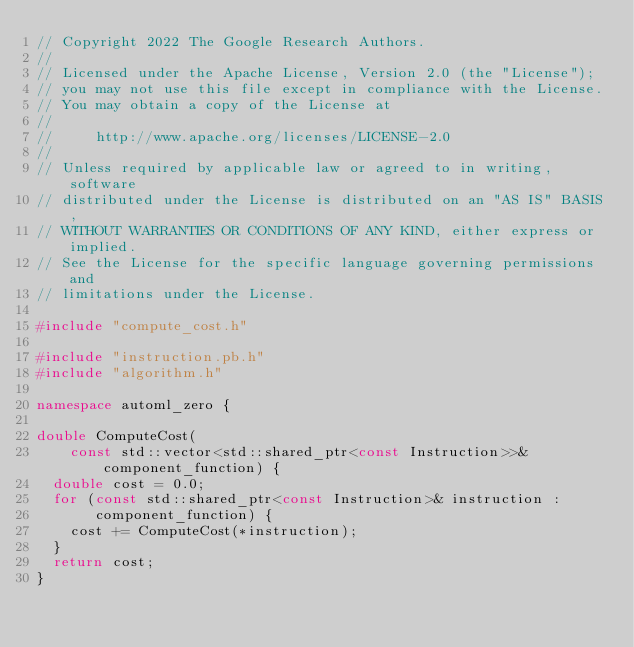<code> <loc_0><loc_0><loc_500><loc_500><_C++_>// Copyright 2022 The Google Research Authors.
//
// Licensed under the Apache License, Version 2.0 (the "License");
// you may not use this file except in compliance with the License.
// You may obtain a copy of the License at
//
//     http://www.apache.org/licenses/LICENSE-2.0
//
// Unless required by applicable law or agreed to in writing, software
// distributed under the License is distributed on an "AS IS" BASIS,
// WITHOUT WARRANTIES OR CONDITIONS OF ANY KIND, either express or implied.
// See the License for the specific language governing permissions and
// limitations under the License.

#include "compute_cost.h"

#include "instruction.pb.h"
#include "algorithm.h"

namespace automl_zero {

double ComputeCost(
    const std::vector<std::shared_ptr<const Instruction>>& component_function) {
  double cost = 0.0;
  for (const std::shared_ptr<const Instruction>& instruction :
       component_function) {
    cost += ComputeCost(*instruction);
  }
  return cost;
}
</code> 